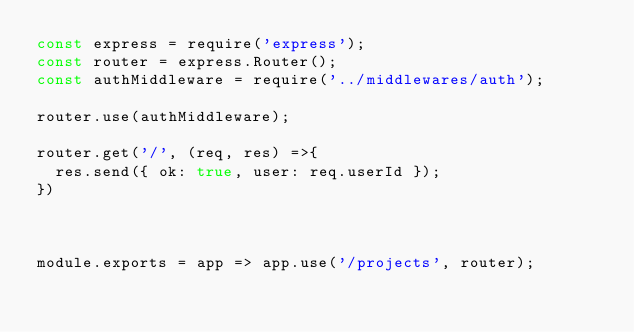Convert code to text. <code><loc_0><loc_0><loc_500><loc_500><_JavaScript_>const express = require('express');
const router = express.Router();
const authMiddleware = require('../middlewares/auth');

router.use(authMiddleware);

router.get('/', (req, res) =>{
  res.send({ ok: true, user: req.userId });
})



module.exports = app => app.use('/projects', router);</code> 